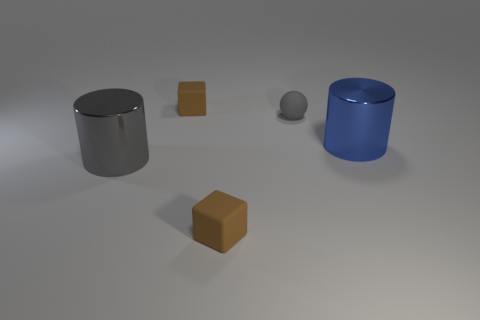There is a blue object; does it have the same size as the object that is behind the matte sphere?
Your answer should be compact. No. What size is the brown block behind the gray cylinder in front of the tiny gray matte thing?
Your response must be concise. Small. How many gray cylinders have the same material as the gray sphere?
Your answer should be very brief. 0. Are there any gray rubber things?
Offer a terse response. Yes. What size is the shiny object that is in front of the blue shiny object?
Offer a terse response. Large. What number of big shiny cylinders are the same color as the matte ball?
Offer a terse response. 1. How many blocks are tiny gray rubber objects or gray shiny things?
Give a very brief answer. 0. What shape is the rubber object that is both on the left side of the small gray matte sphere and behind the blue cylinder?
Make the answer very short. Cube. Are there any gray metallic cylinders of the same size as the gray matte thing?
Ensure brevity in your answer.  No. How many things are either tiny matte cubes that are behind the large blue thing or blue cylinders?
Your answer should be compact. 2. 